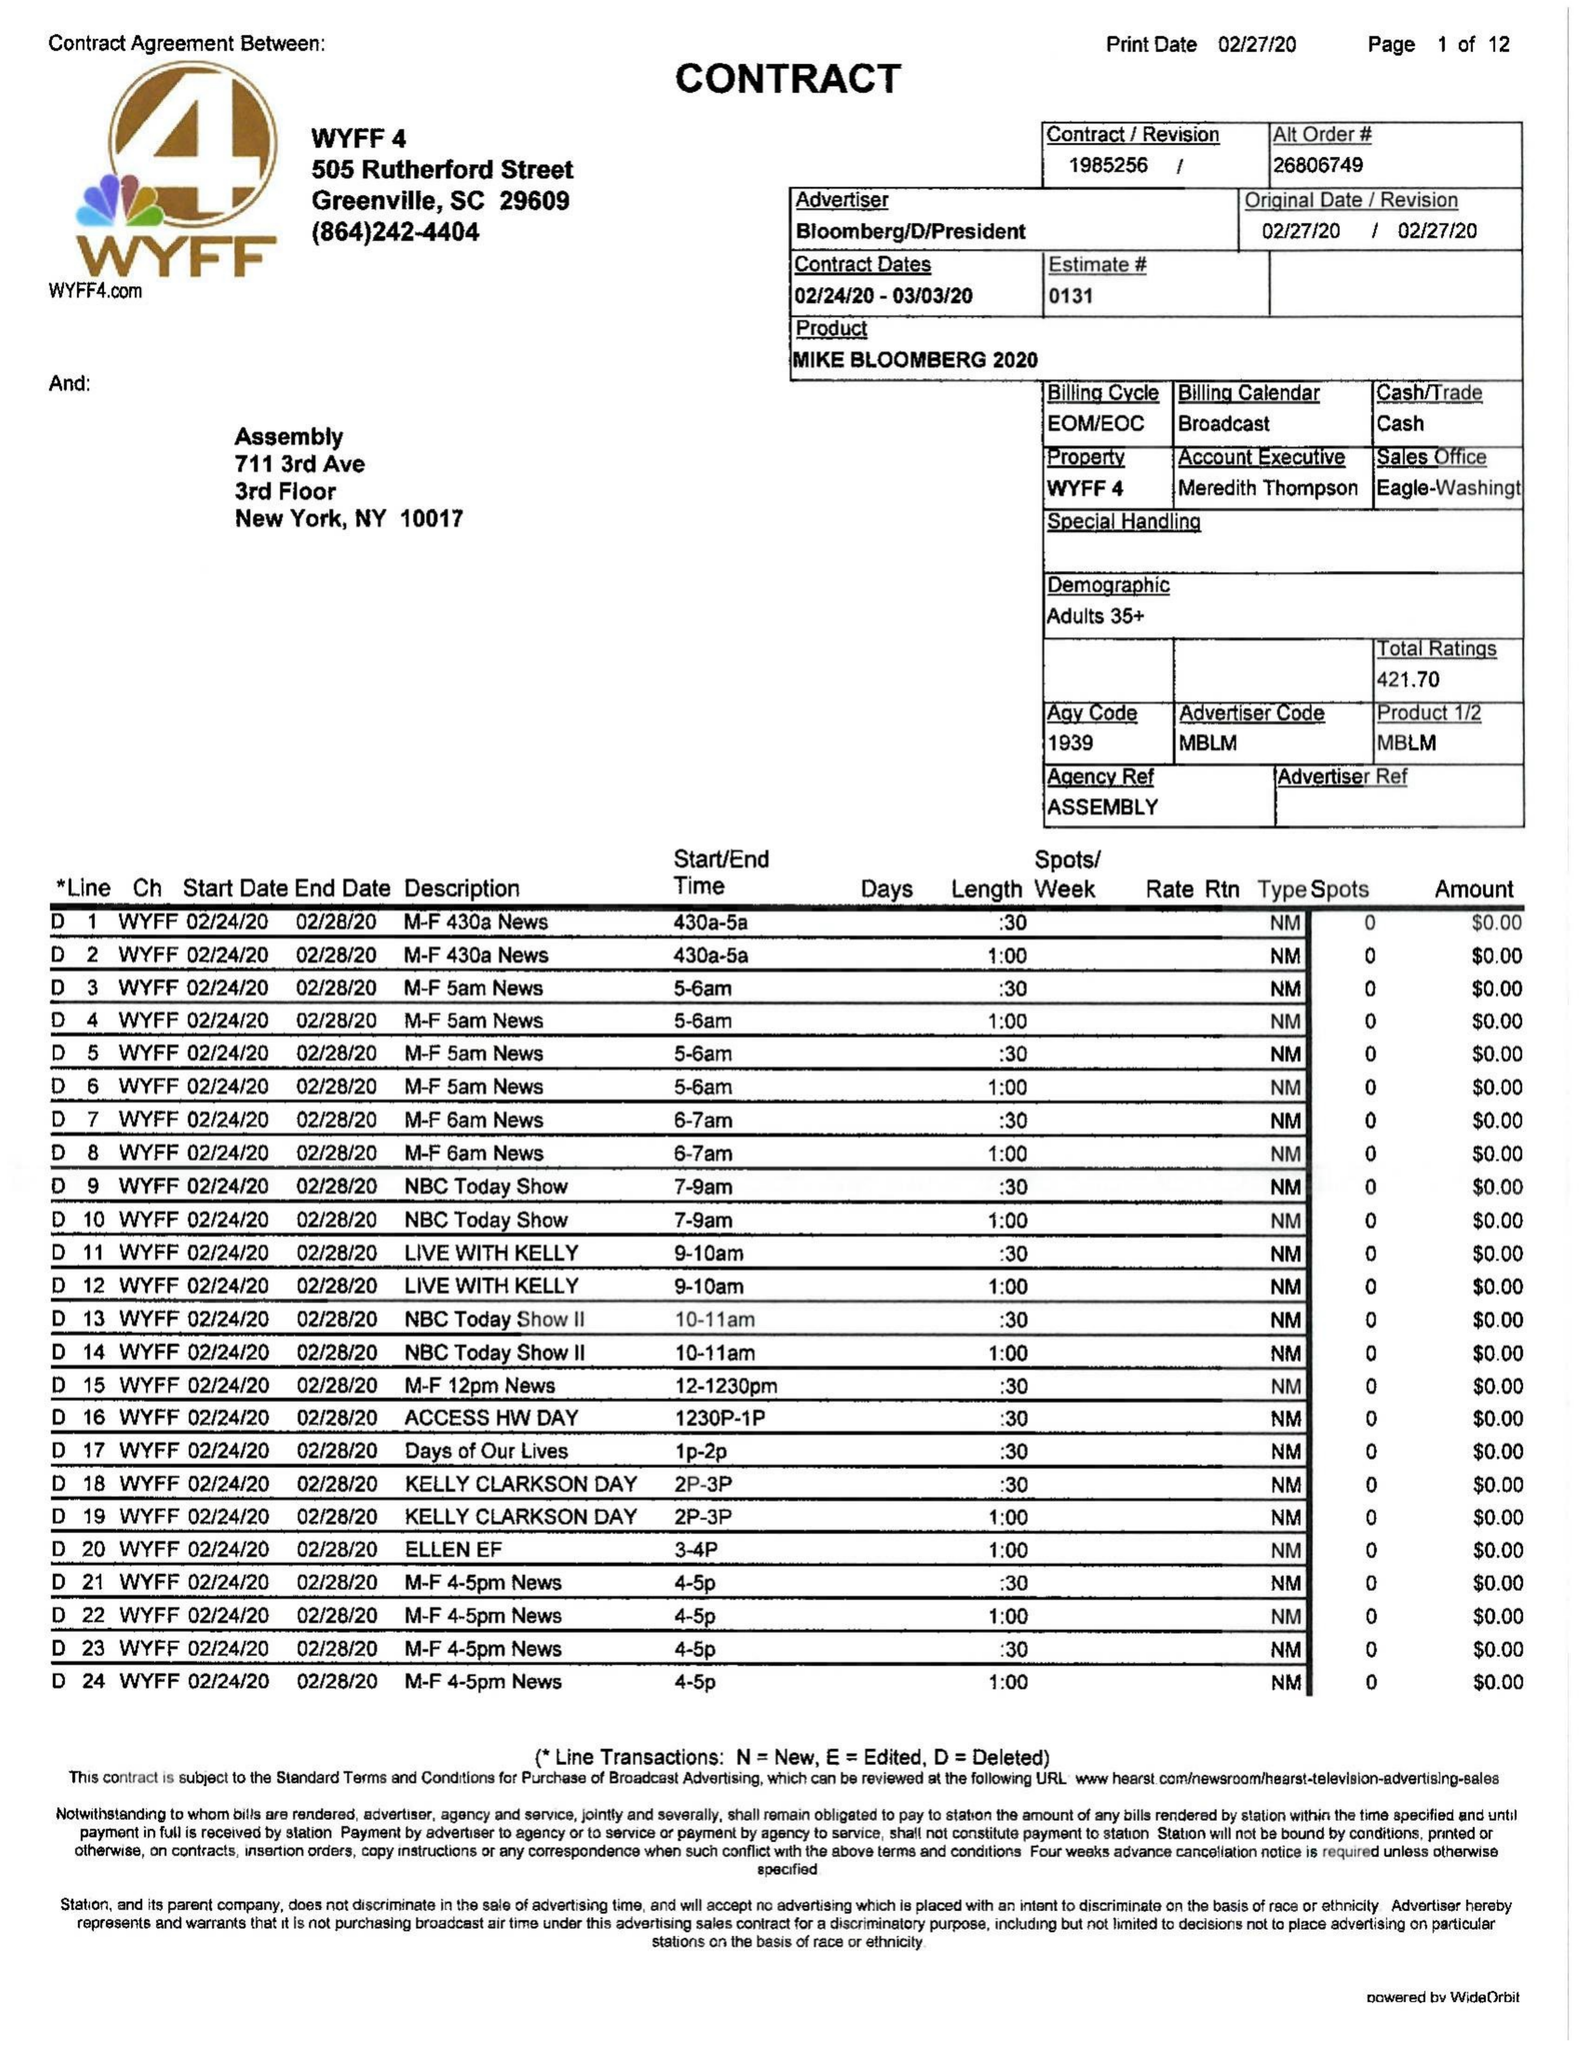What is the value for the contract_num?
Answer the question using a single word or phrase. 1985256 